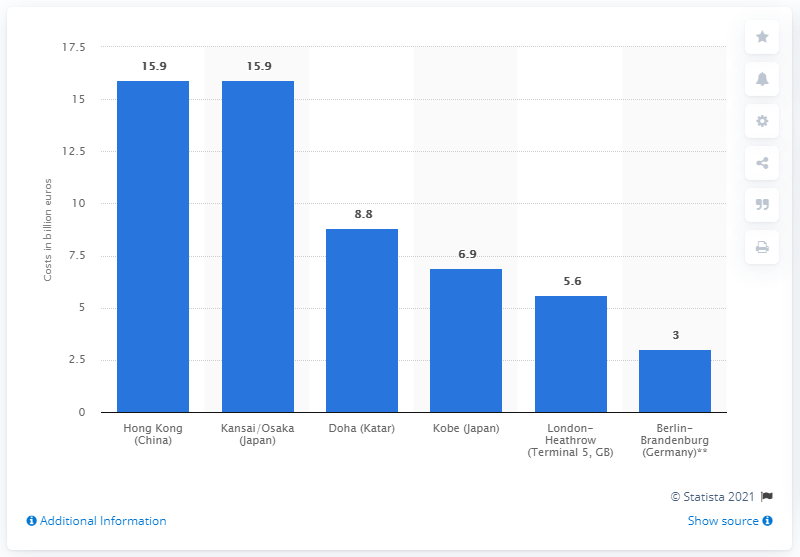List a handful of essential elements in this visual. The construction cost for the Berlin-Brandenburg Airport was approximately 3 billion euros. 